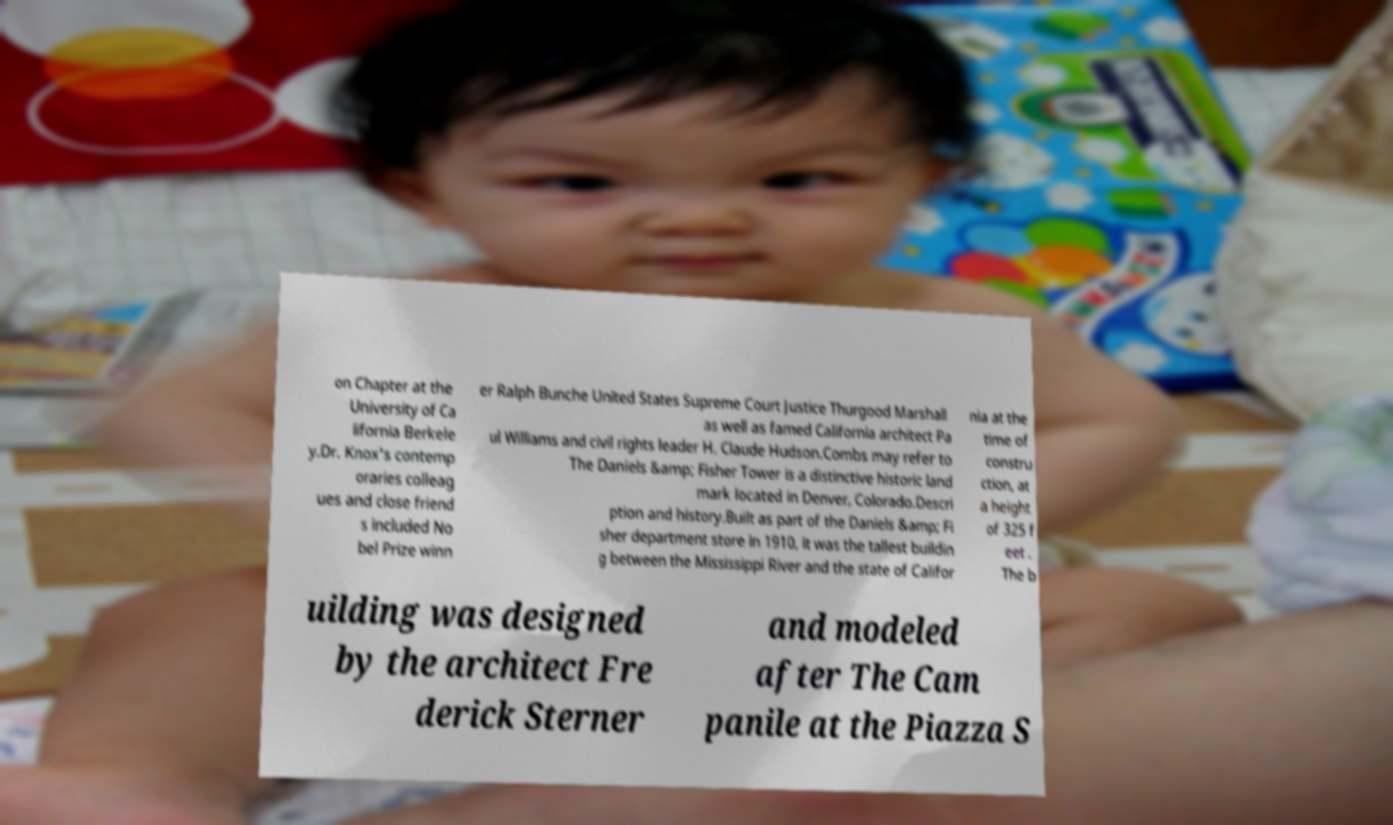Can you read and provide the text displayed in the image?This photo seems to have some interesting text. Can you extract and type it out for me? on Chapter at the University of Ca lifornia Berkele y.Dr. Knox's contemp oraries colleag ues and close friend s included No bel Prize winn er Ralph Bunche United States Supreme Court Justice Thurgood Marshall as well as famed California architect Pa ul Williams and civil rights leader H. Claude Hudson.Combs may refer to The Daniels &amp; Fisher Tower is a distinctive historic land mark located in Denver, Colorado.Descri ption and history.Built as part of the Daniels &amp; Fi sher department store in 1910, it was the tallest buildin g between the Mississippi River and the state of Califor nia at the time of constru ction, at a height of 325 f eet . The b uilding was designed by the architect Fre derick Sterner and modeled after The Cam panile at the Piazza S 